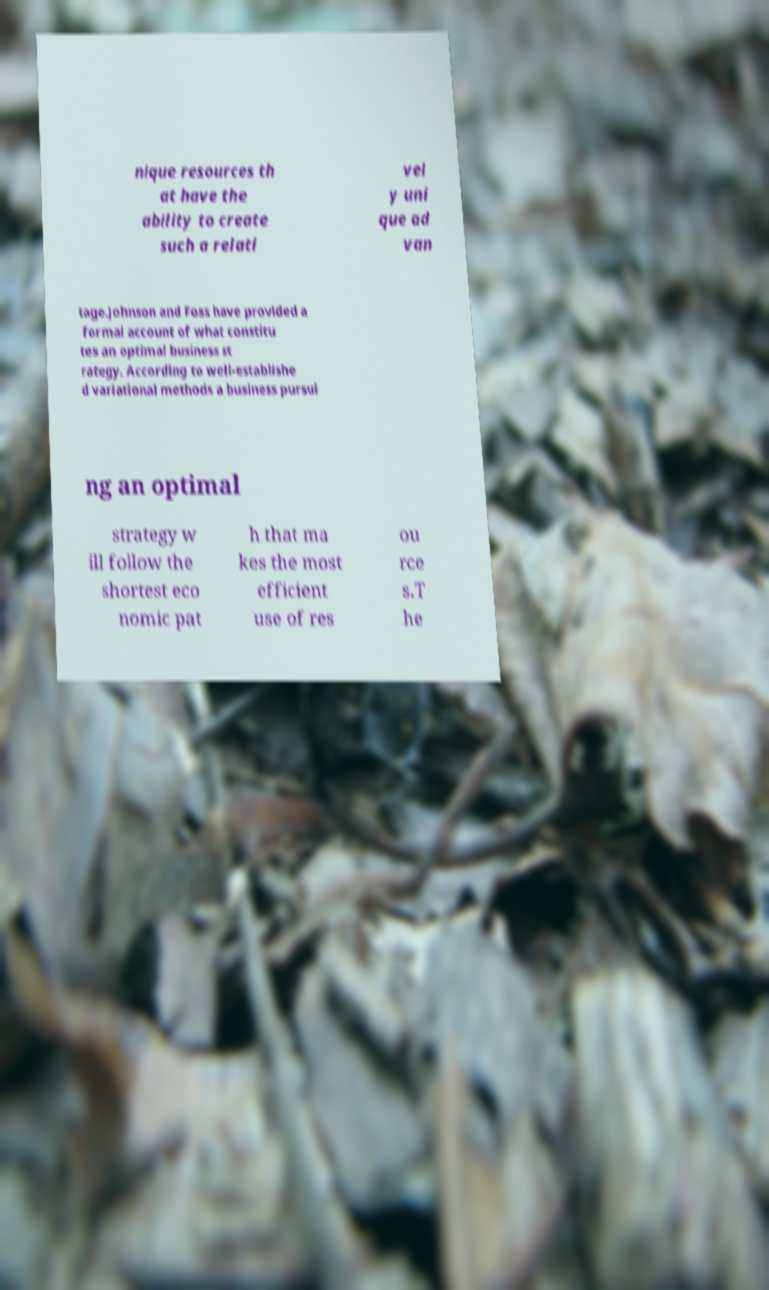What messages or text are displayed in this image? I need them in a readable, typed format. nique resources th at have the ability to create such a relati vel y uni que ad van tage.Johnson and Foss have provided a formal account of what constitu tes an optimal business st rategy. According to well-establishe d variational methods a business pursui ng an optimal strategy w ill follow the shortest eco nomic pat h that ma kes the most efficient use of res ou rce s.T he 